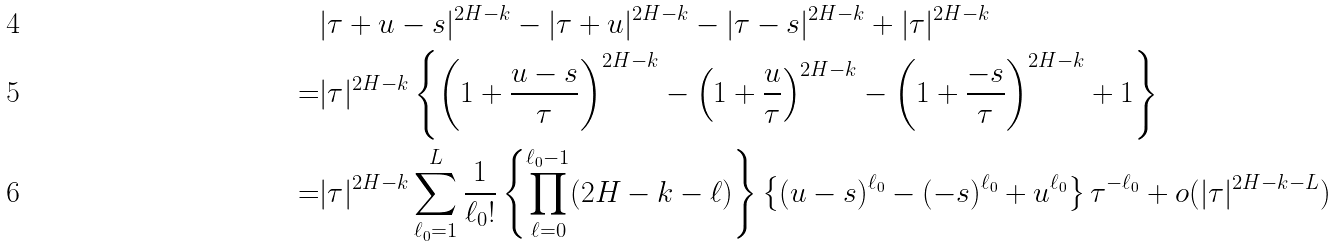<formula> <loc_0><loc_0><loc_500><loc_500>& | \tau + u - s | ^ { 2 H - k } - | \tau + u | ^ { 2 H - k } - | \tau - s | ^ { 2 H - k } + | \tau | ^ { 2 H - k } \\ = & | \tau | ^ { 2 H - k } \left \{ \left ( 1 + \frac { u - s } { \tau } \right ) ^ { 2 H - k } - \left ( 1 + \frac { u } { \tau } \right ) ^ { 2 H - k } - \left ( 1 + \frac { - s } { \tau } \right ) ^ { 2 H - k } + 1 \right \} \\ = & | \tau | ^ { 2 H - k } \sum _ { \ell _ { 0 } = 1 } ^ { L } \frac { 1 } { \ell _ { 0 } ! } \left \{ \prod _ { \ell = 0 } ^ { \ell _ { 0 } - 1 } ( 2 H - k - \ell ) \right \} \left \{ ( u - s ) ^ { \ell _ { 0 } } - ( - s ) ^ { \ell _ { 0 } } + u ^ { \ell _ { 0 } } \right \} \tau ^ { - \ell _ { 0 } } + o ( | \tau | ^ { 2 H - k - L } )</formula> 